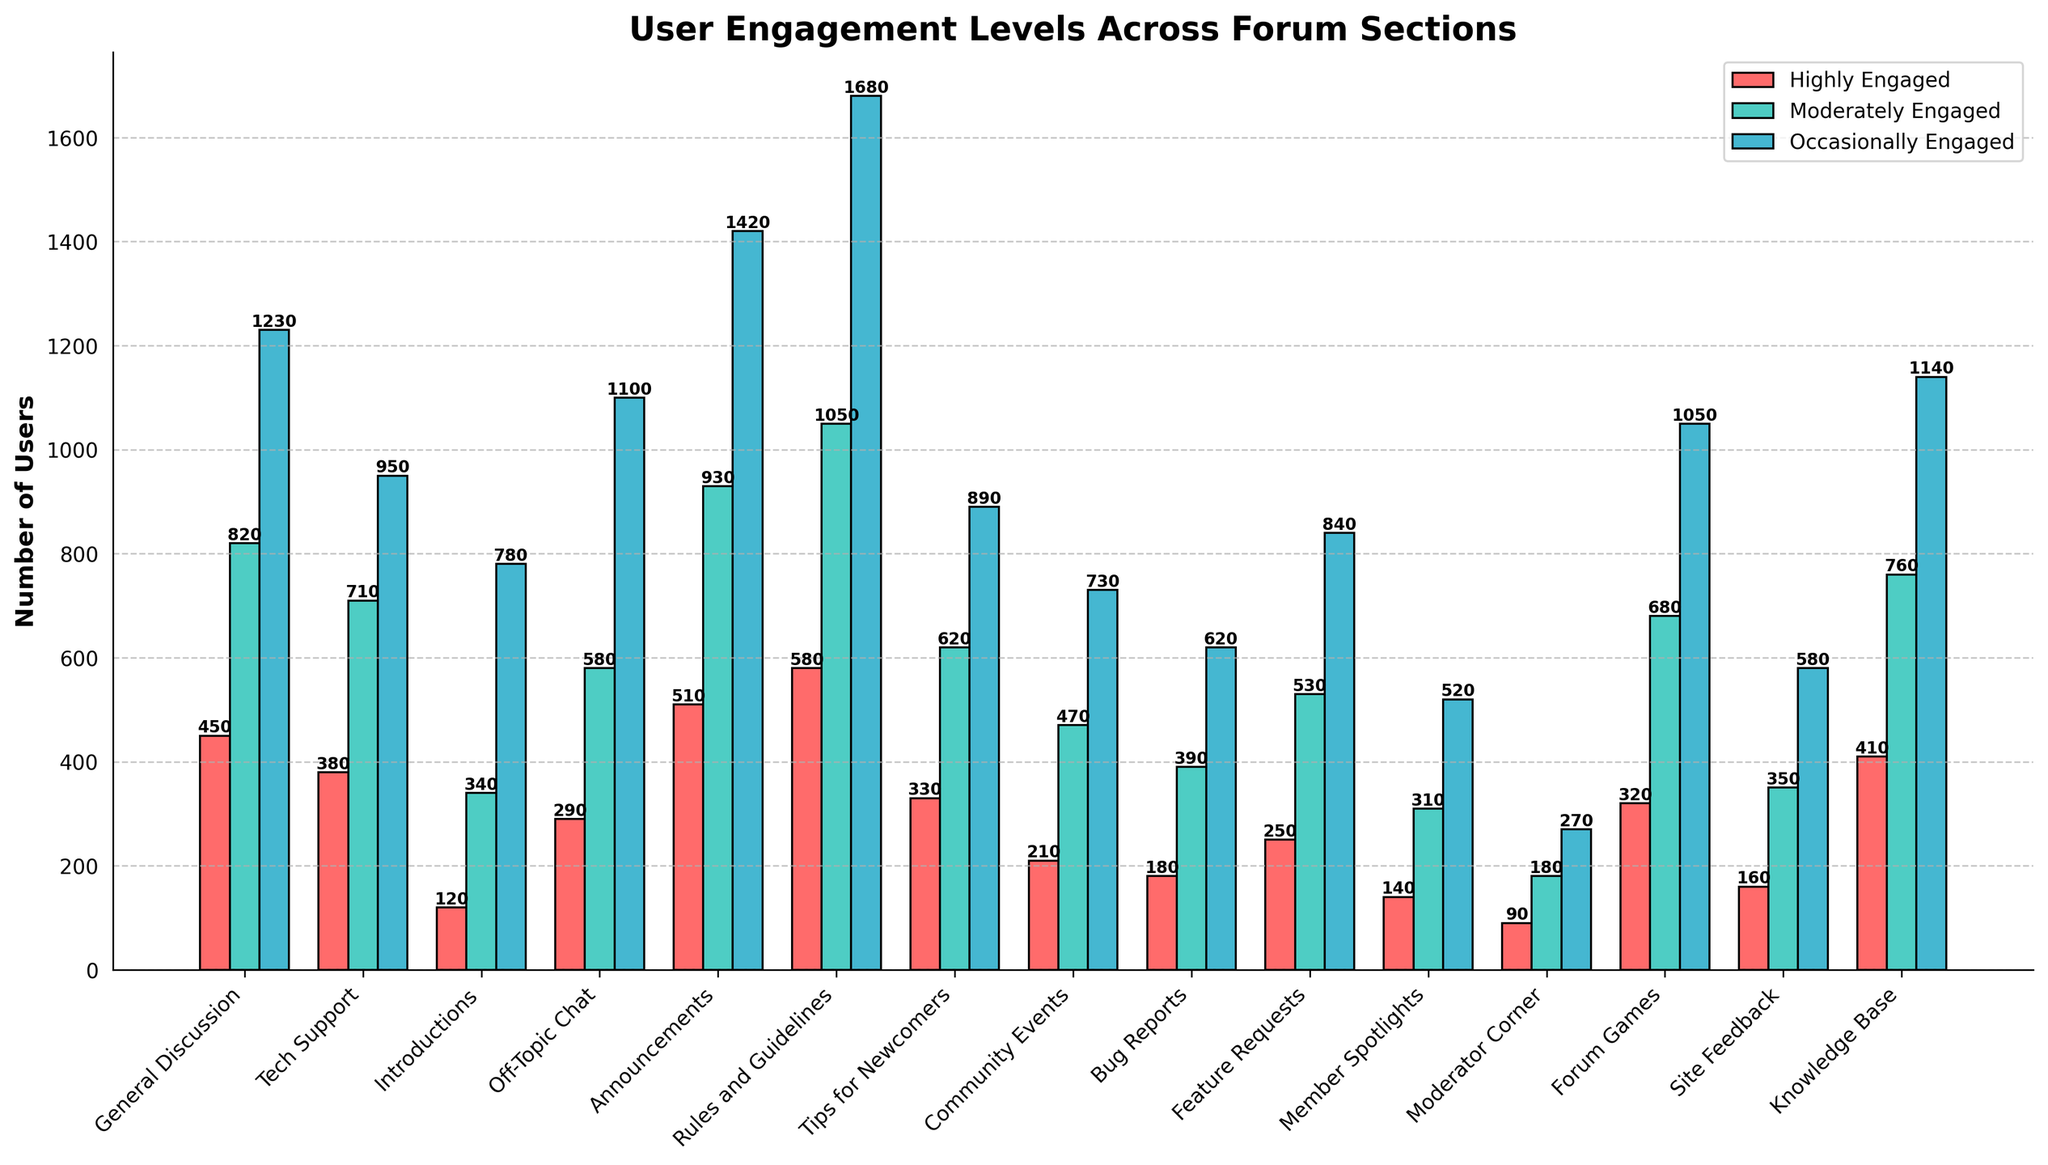Which forum section has the highest number of highly engaged users? To find the section with the highest number of highly engaged users, look at the heights of the red bars in the figure. The 'Rules and Guidelines' section has the highest red bar indicating 580 highly engaged users.
Answer: Rules and Guidelines Compare the number of highly engaged and moderately engaged users in the 'Announcements' section. Which group is larger? Locate the 'Announcements' section in the figure and compare the red (highly engaged) bar with the green (moderately engaged) bar. The green bar is taller, indicating more moderately engaged users (930) compared to highly engaged users (510).
Answer: Moderately engaged Which three sections have the lowest number of highly engaged users? Identify the three shortest red bars in the figure. 'Moderator Corner' has 90, 'Bug Reports' has 180, and 'Member Spotlights' has 140 highly engaged users.
Answer: Moderator Corner, Member Spotlights, Bug Reports What is the total number of regularly engaged users in the 'General Discussion' and 'Off-Topic Chat' sections? For both sections, add the value of the red, green, and blue bars and sum the results: (450 + 820 + 1230) for 'General Discussion' and (290 + 580 + 1100) for 'Off-Topic Chat'. The sum is 2500 (General Discussion) + 1970 (Off-Topic Chat) = 4470.
Answer: 4470 Which section has more highly engaged users: 'Tech Support' or 'Tips for Newcomers'? Compare the red bar heights of 'Tech Support' and 'Tips for Newcomers'. 'Tech Support' has 380 highly engaged users while 'Tips for Newcomers' has 330.
Answer: Tech Support How many more users are highly engaged in 'Knowledge Base' compared to 'Site Feedback'? Subtract the number of highly engaged users in 'Site Feedback' (160) from those in 'Knowledge Base' (410). The difference is 410 - 160 = 250.
Answer: 250 Which three sections have the highest number of occasionally engaged users? Identify the three tallest blue bars in the figure. The 'Rules and Guidelines' (1680), 'Announcements' (1420), and 'General Discussion' (1230) sections have the highest number of occasionally engaged users.
Answer: Rules and Guidelines, Announcements, General Discussion What is the average number of moderately engaged users across all sections? Add the values of the green bars from all sections and divide by the number of sections (15): (820 + 710 + 340 + 580 + 930 + 1050 + 620 + 470 + 390 + 530 + 310 + 180 + 680 + 350 + 760) / 15. The total is 8720; the average is 8720 / 15 = 581.33.
Answer: 581.33 In which section do occasionally engaged users outnumber the combined sum of highly and moderately engaged users? For each section, compare the blue bar to the combined height of red and green bars. Occasional users outnumber the combined grouped users in no sections in the given dataset.
Answer: None 